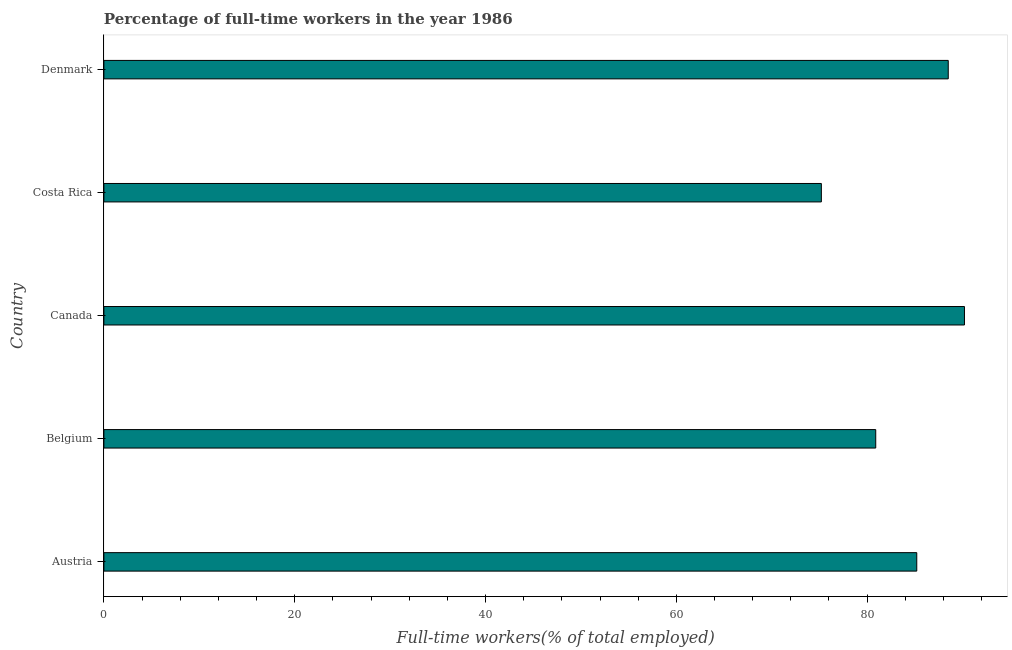Does the graph contain any zero values?
Your answer should be compact. No. Does the graph contain grids?
Your answer should be very brief. No. What is the title of the graph?
Keep it short and to the point. Percentage of full-time workers in the year 1986. What is the label or title of the X-axis?
Offer a very short reply. Full-time workers(% of total employed). What is the percentage of full-time workers in Costa Rica?
Make the answer very short. 75.2. Across all countries, what is the maximum percentage of full-time workers?
Your answer should be very brief. 90.2. Across all countries, what is the minimum percentage of full-time workers?
Keep it short and to the point. 75.2. In which country was the percentage of full-time workers minimum?
Give a very brief answer. Costa Rica. What is the sum of the percentage of full-time workers?
Your answer should be compact. 420. What is the difference between the percentage of full-time workers in Austria and Costa Rica?
Provide a succinct answer. 10. What is the median percentage of full-time workers?
Your answer should be very brief. 85.2. What is the ratio of the percentage of full-time workers in Belgium to that in Canada?
Your answer should be compact. 0.9. Is the percentage of full-time workers in Austria less than that in Costa Rica?
Offer a terse response. No. Is the difference between the percentage of full-time workers in Austria and Canada greater than the difference between any two countries?
Your answer should be very brief. No. Is the sum of the percentage of full-time workers in Austria and Costa Rica greater than the maximum percentage of full-time workers across all countries?
Your response must be concise. Yes. What is the difference between the highest and the lowest percentage of full-time workers?
Your answer should be compact. 15. Are all the bars in the graph horizontal?
Make the answer very short. Yes. How many countries are there in the graph?
Ensure brevity in your answer.  5. What is the difference between two consecutive major ticks on the X-axis?
Keep it short and to the point. 20. Are the values on the major ticks of X-axis written in scientific E-notation?
Provide a short and direct response. No. What is the Full-time workers(% of total employed) in Austria?
Give a very brief answer. 85.2. What is the Full-time workers(% of total employed) in Belgium?
Give a very brief answer. 80.9. What is the Full-time workers(% of total employed) in Canada?
Your answer should be very brief. 90.2. What is the Full-time workers(% of total employed) in Costa Rica?
Your answer should be very brief. 75.2. What is the Full-time workers(% of total employed) in Denmark?
Ensure brevity in your answer.  88.5. What is the difference between the Full-time workers(% of total employed) in Austria and Canada?
Your answer should be very brief. -5. What is the difference between the Full-time workers(% of total employed) in Austria and Costa Rica?
Make the answer very short. 10. What is the difference between the Full-time workers(% of total employed) in Belgium and Denmark?
Offer a terse response. -7.6. What is the ratio of the Full-time workers(% of total employed) in Austria to that in Belgium?
Make the answer very short. 1.05. What is the ratio of the Full-time workers(% of total employed) in Austria to that in Canada?
Your answer should be compact. 0.94. What is the ratio of the Full-time workers(% of total employed) in Austria to that in Costa Rica?
Provide a short and direct response. 1.13. What is the ratio of the Full-time workers(% of total employed) in Austria to that in Denmark?
Offer a very short reply. 0.96. What is the ratio of the Full-time workers(% of total employed) in Belgium to that in Canada?
Provide a short and direct response. 0.9. What is the ratio of the Full-time workers(% of total employed) in Belgium to that in Costa Rica?
Provide a succinct answer. 1.08. What is the ratio of the Full-time workers(% of total employed) in Belgium to that in Denmark?
Ensure brevity in your answer.  0.91. What is the ratio of the Full-time workers(% of total employed) in Canada to that in Costa Rica?
Your response must be concise. 1.2. What is the ratio of the Full-time workers(% of total employed) in Canada to that in Denmark?
Offer a terse response. 1.02. 